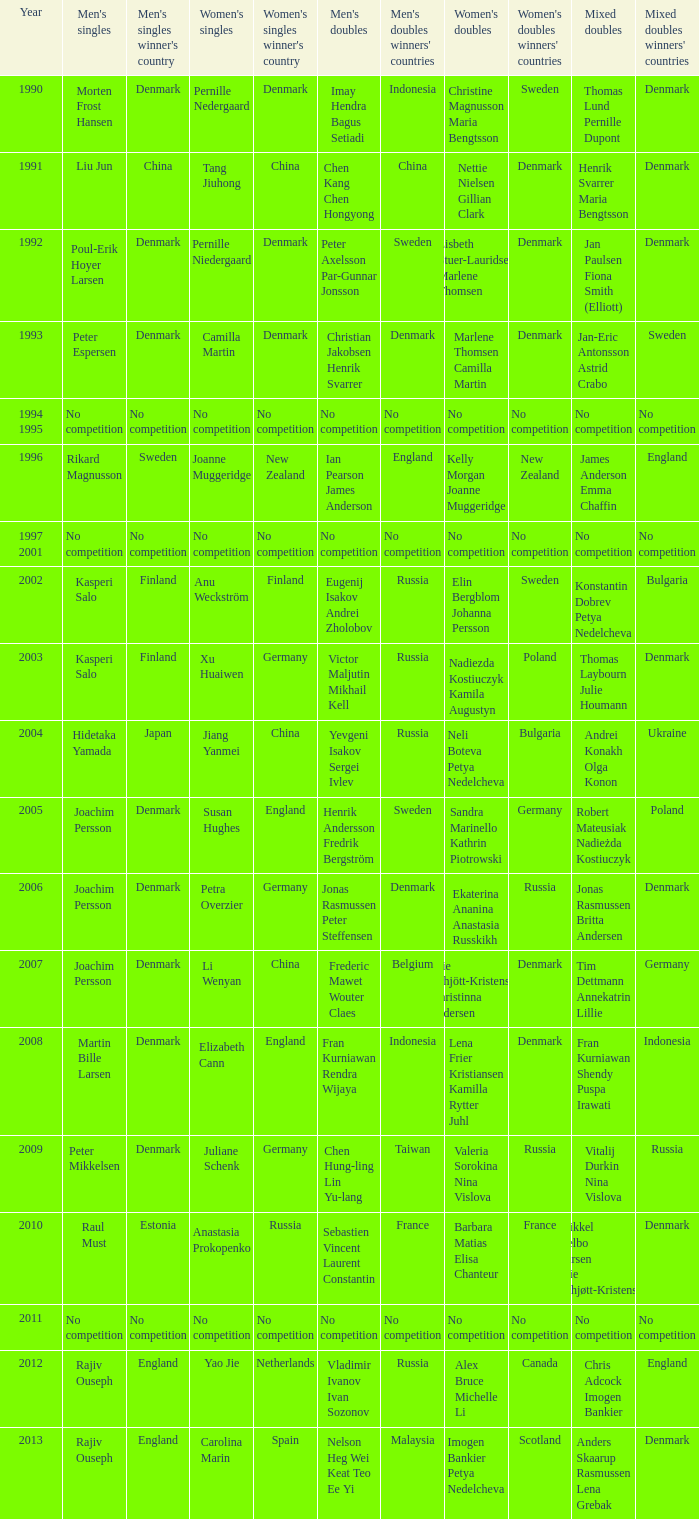Who won the Mixed Doubles in 2007? Tim Dettmann Annekatrin Lillie. 